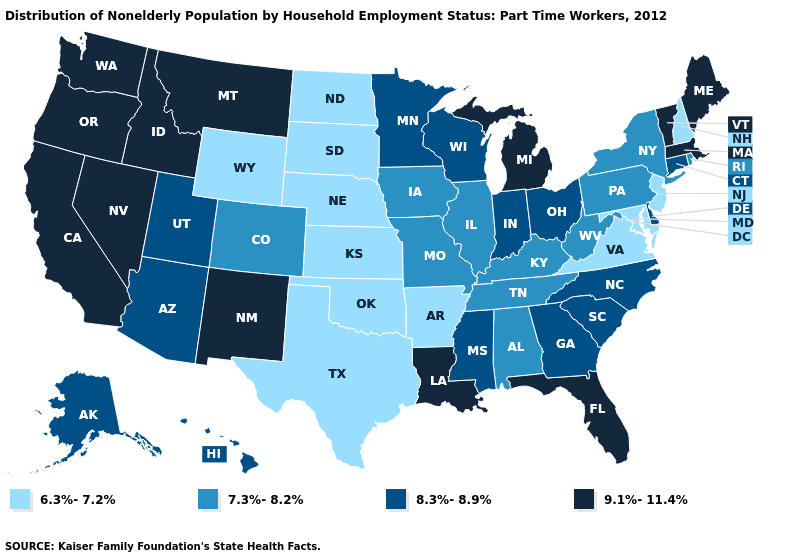What is the value of Louisiana?
Quick response, please. 9.1%-11.4%. Does Oklahoma have the lowest value in the South?
Keep it brief. Yes. Which states hav the highest value in the MidWest?
Write a very short answer. Michigan. Does Virginia have a lower value than Maryland?
Write a very short answer. No. Does West Virginia have the lowest value in the South?
Write a very short answer. No. Which states have the highest value in the USA?
Concise answer only. California, Florida, Idaho, Louisiana, Maine, Massachusetts, Michigan, Montana, Nevada, New Mexico, Oregon, Vermont, Washington. Does Georgia have the highest value in the USA?
Be succinct. No. Does Nevada have a higher value than Oklahoma?
Quick response, please. Yes. Name the states that have a value in the range 8.3%-8.9%?
Answer briefly. Alaska, Arizona, Connecticut, Delaware, Georgia, Hawaii, Indiana, Minnesota, Mississippi, North Carolina, Ohio, South Carolina, Utah, Wisconsin. What is the value of Connecticut?
Concise answer only. 8.3%-8.9%. Among the states that border Virginia , does West Virginia have the lowest value?
Answer briefly. No. Does the first symbol in the legend represent the smallest category?
Be succinct. Yes. What is the value of Rhode Island?
Write a very short answer. 7.3%-8.2%. Does Vermont have the highest value in the USA?
Keep it brief. Yes. Does North Carolina have a lower value than Montana?
Answer briefly. Yes. 